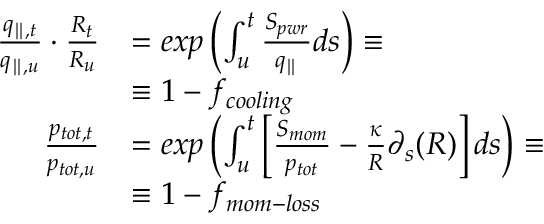Convert formula to latex. <formula><loc_0><loc_0><loc_500><loc_500>\begin{array} { r l } { \frac { q _ { \| , t } } { q _ { \| , u } } \cdot \frac { R _ { t } } { R _ { u } } } & { = e x p \left ( \int _ { u } ^ { t } \frac { S _ { p w r } } { q _ { \| } } d s \right ) \equiv } & { \equiv 1 - f _ { c o o l i n g } } \\ { \frac { p _ { t o t , t } } { p _ { t o t , u } } } & { = e x p \left ( \int _ { u } ^ { t } \left [ \frac { S _ { m o m } } { p _ { t o t } } - \frac { \kappa } { R } \partial _ { s } ( R ) \right ] d s \right ) \equiv } & { \equiv 1 - f _ { m o m - l o s s } } \end{array}</formula> 